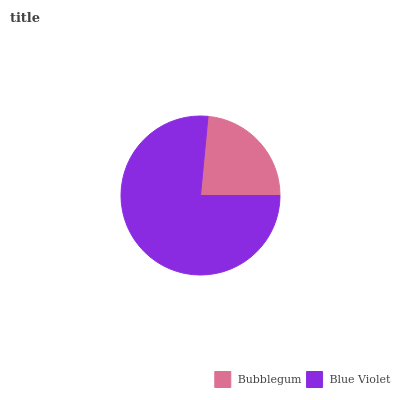Is Bubblegum the minimum?
Answer yes or no. Yes. Is Blue Violet the maximum?
Answer yes or no. Yes. Is Blue Violet the minimum?
Answer yes or no. No. Is Blue Violet greater than Bubblegum?
Answer yes or no. Yes. Is Bubblegum less than Blue Violet?
Answer yes or no. Yes. Is Bubblegum greater than Blue Violet?
Answer yes or no. No. Is Blue Violet less than Bubblegum?
Answer yes or no. No. Is Blue Violet the high median?
Answer yes or no. Yes. Is Bubblegum the low median?
Answer yes or no. Yes. Is Bubblegum the high median?
Answer yes or no. No. Is Blue Violet the low median?
Answer yes or no. No. 